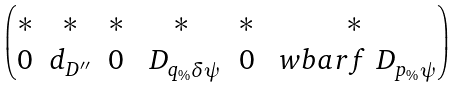Convert formula to latex. <formula><loc_0><loc_0><loc_500><loc_500>\begin{pmatrix} * & * & * & * & * & * \\ 0 & d _ { D ^ { \prime \prime } } & 0 & \ D _ { q _ { \% } \delta \psi } & 0 & \ w b a r f \ D _ { p _ { \% } \psi } \end{pmatrix}</formula> 